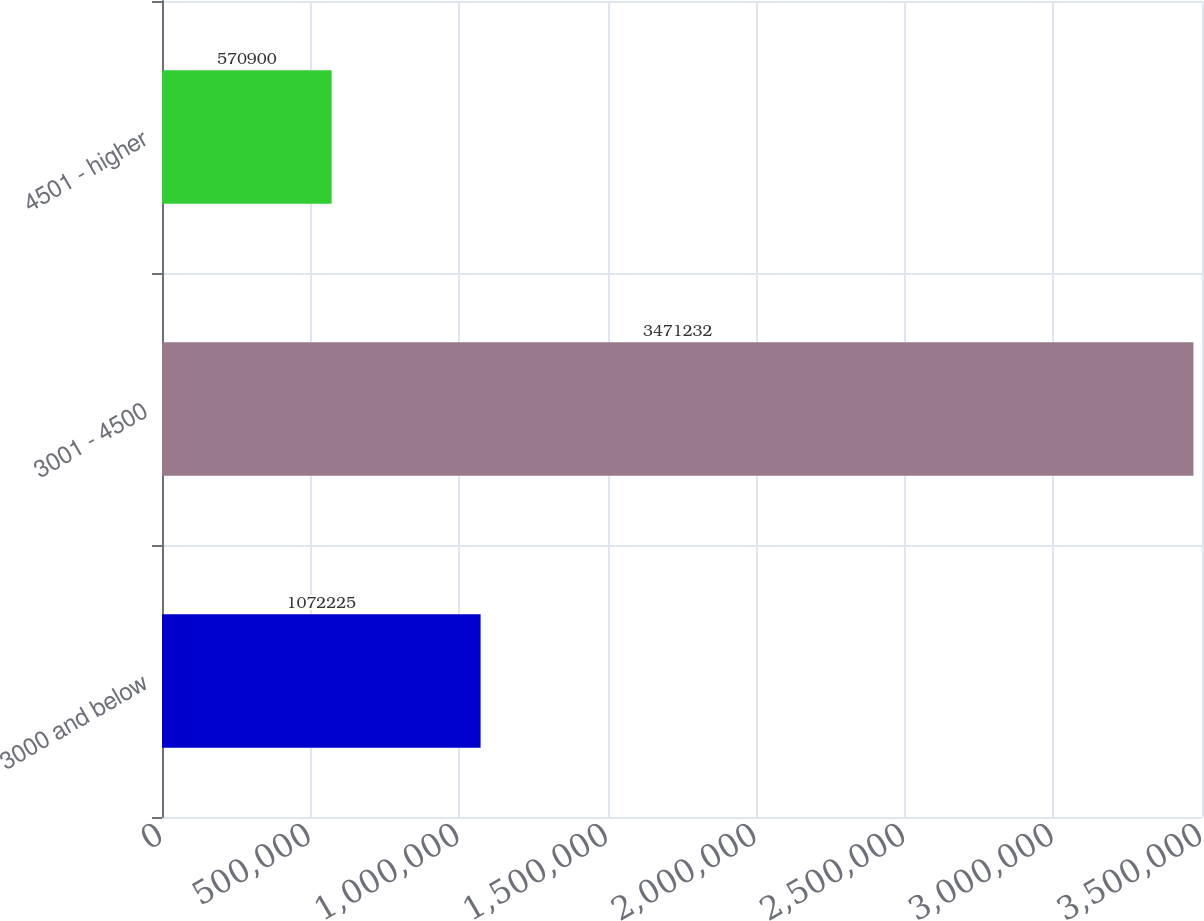Convert chart. <chart><loc_0><loc_0><loc_500><loc_500><bar_chart><fcel>3000 and below<fcel>3001 - 4500<fcel>4501 - higher<nl><fcel>1.07222e+06<fcel>3.47123e+06<fcel>570900<nl></chart> 